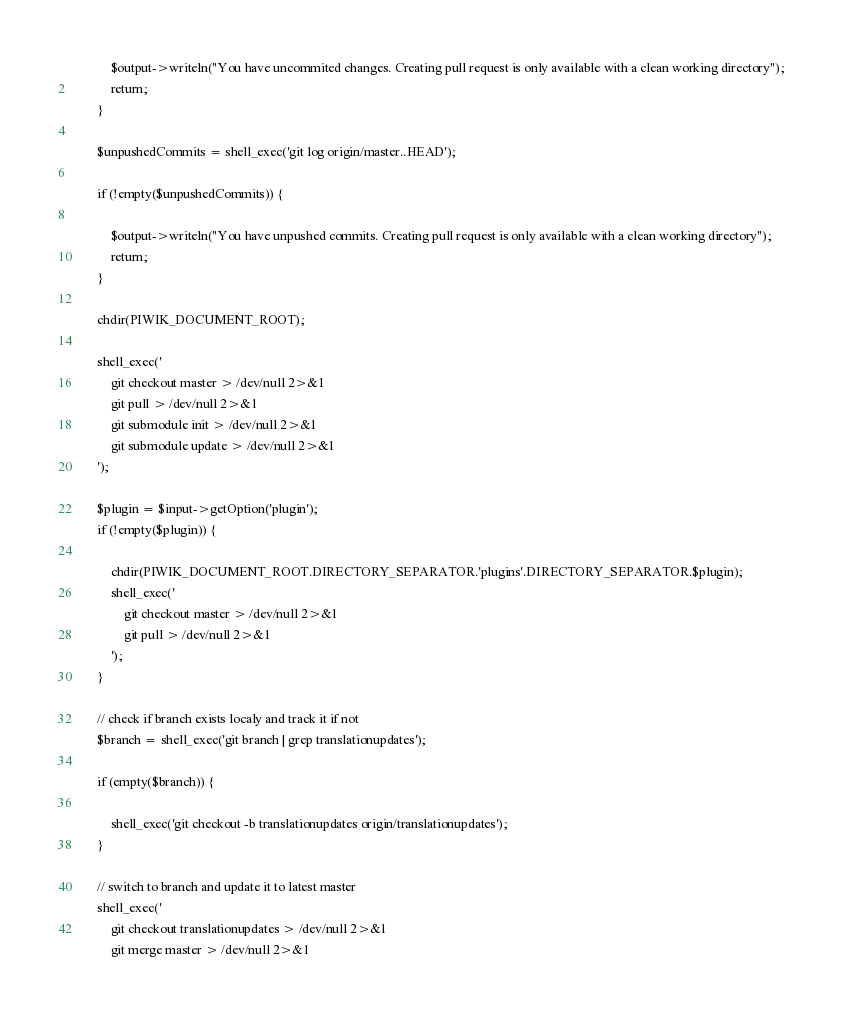Convert code to text. <code><loc_0><loc_0><loc_500><loc_500><_PHP_>
            $output->writeln("You have uncommited changes. Creating pull request is only available with a clean working directory");
            return;
        }

        $unpushedCommits = shell_exec('git log origin/master..HEAD');

        if (!empty($unpushedCommits)) {

            $output->writeln("You have unpushed commits. Creating pull request is only available with a clean working directory");
            return;
        }

        chdir(PIWIK_DOCUMENT_ROOT);

        shell_exec('
            git checkout master > /dev/null 2>&1
            git pull > /dev/null 2>&1
            git submodule init > /dev/null 2>&1
            git submodule update > /dev/null 2>&1
        ');

        $plugin = $input->getOption('plugin');
        if (!empty($plugin)) {

            chdir(PIWIK_DOCUMENT_ROOT.DIRECTORY_SEPARATOR.'plugins'.DIRECTORY_SEPARATOR.$plugin);
            shell_exec('
                git checkout master > /dev/null 2>&1
                git pull > /dev/null 2>&1
            ');
        }

        // check if branch exists localy and track it if not
        $branch = shell_exec('git branch | grep translationupdates');

        if (empty($branch)) {

            shell_exec('git checkout -b translationupdates origin/translationupdates');
        }

        // switch to branch and update it to latest master
        shell_exec('
            git checkout translationupdates > /dev/null 2>&1
            git merge master > /dev/null 2>&1</code> 